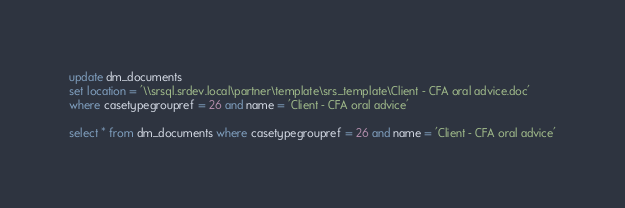Convert code to text. <code><loc_0><loc_0><loc_500><loc_500><_SQL_>

update dm_documents 
set location = '\\srsql.srdev.local\partner\template\srs_template\Client - CFA oral advice.doc'
where casetypegroupref = 26 and name = 'Client - CFA oral advice'

select * from dm_documents where casetypegroupref = 26 and name = 'Client - CFA oral advice'</code> 